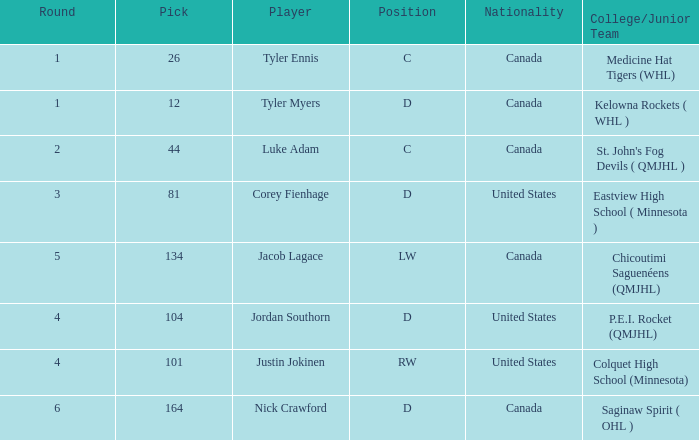What is the college/junior team of player tyler myers, who has a pick less than 44? Kelowna Rockets ( WHL ). 